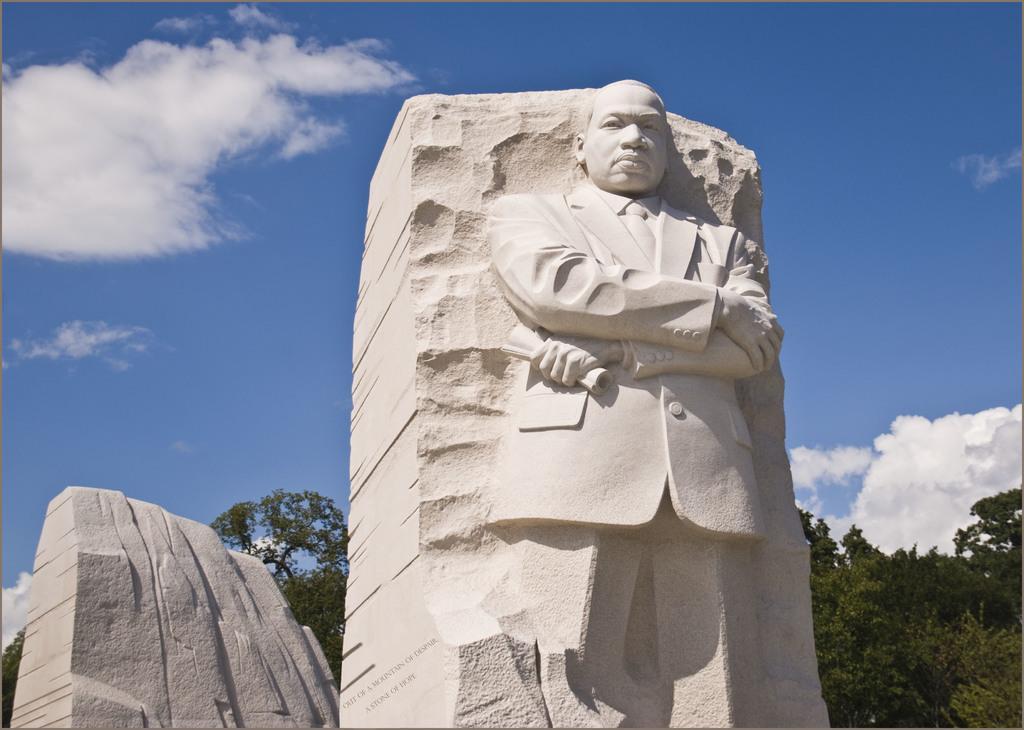Please provide a concise description of this image. In this image there is the sky, there are clouds in the sky, there are trees, there is a sculpture of a person. 